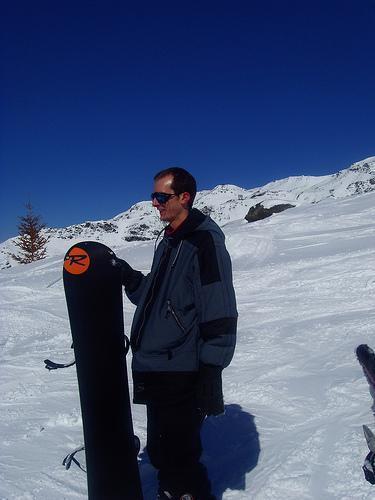How many people are in the photo?
Give a very brief answer. 1. 